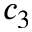<formula> <loc_0><loc_0><loc_500><loc_500>c _ { 3 }</formula> 